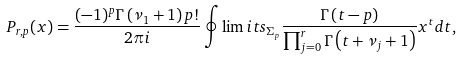Convert formula to latex. <formula><loc_0><loc_0><loc_500><loc_500>P _ { r , p } ( x ) = \frac { ( - 1 ) ^ { p } \Gamma \left ( \nu _ { 1 } + 1 \right ) p ! } { 2 \pi i } \oint \lim i t s _ { \Sigma _ { p } } \frac { \Gamma \left ( t - p \right ) } { \prod _ { j = 0 } ^ { r } \Gamma \left ( t + \nu _ { j } + 1 \right ) } x ^ { t } d t ,</formula> 